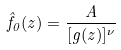Convert formula to latex. <formula><loc_0><loc_0><loc_500><loc_500>\hat { f } _ { 0 } ( z ) = \frac { A } { [ g ( z ) ] ^ { \nu } }</formula> 